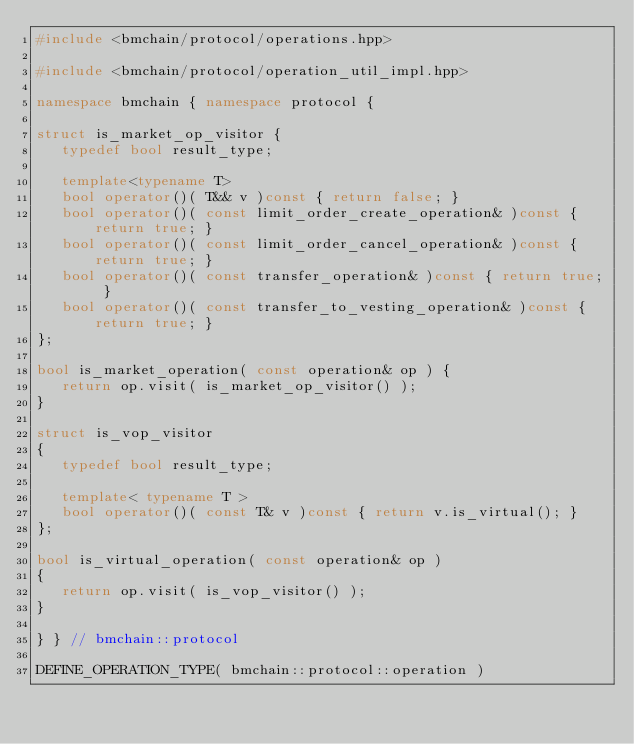Convert code to text. <code><loc_0><loc_0><loc_500><loc_500><_C++_>#include <bmchain/protocol/operations.hpp>

#include <bmchain/protocol/operation_util_impl.hpp>

namespace bmchain { namespace protocol {

struct is_market_op_visitor {
   typedef bool result_type;

   template<typename T>
   bool operator()( T&& v )const { return false; }
   bool operator()( const limit_order_create_operation& )const { return true; }
   bool operator()( const limit_order_cancel_operation& )const { return true; }
   bool operator()( const transfer_operation& )const { return true; }
   bool operator()( const transfer_to_vesting_operation& )const { return true; }
};

bool is_market_operation( const operation& op ) {
   return op.visit( is_market_op_visitor() );
}

struct is_vop_visitor
{
   typedef bool result_type;

   template< typename T >
   bool operator()( const T& v )const { return v.is_virtual(); }
};

bool is_virtual_operation( const operation& op )
{
   return op.visit( is_vop_visitor() );
}

} } // bmchain::protocol

DEFINE_OPERATION_TYPE( bmchain::protocol::operation )
</code> 